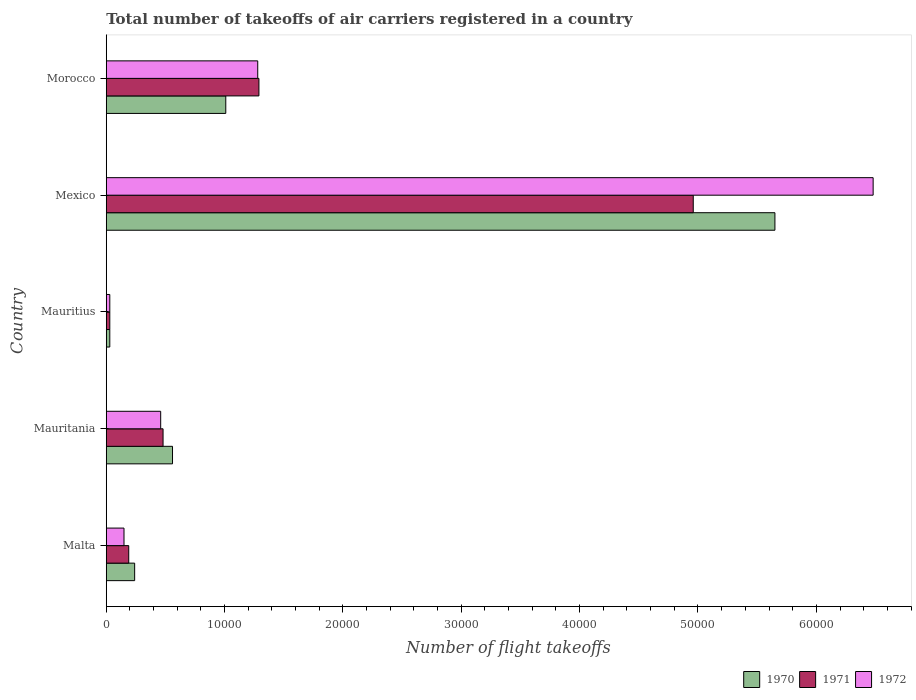How many groups of bars are there?
Keep it short and to the point. 5. How many bars are there on the 4th tick from the bottom?
Provide a short and direct response. 3. What is the label of the 3rd group of bars from the top?
Your response must be concise. Mauritius. What is the total number of flight takeoffs in 1970 in Mauritius?
Your answer should be very brief. 300. Across all countries, what is the maximum total number of flight takeoffs in 1971?
Your answer should be very brief. 4.96e+04. Across all countries, what is the minimum total number of flight takeoffs in 1972?
Offer a very short reply. 300. In which country was the total number of flight takeoffs in 1971 minimum?
Keep it short and to the point. Mauritius. What is the total total number of flight takeoffs in 1971 in the graph?
Ensure brevity in your answer.  6.95e+04. What is the difference between the total number of flight takeoffs in 1970 in Mexico and that in Morocco?
Keep it short and to the point. 4.64e+04. What is the difference between the total number of flight takeoffs in 1970 in Morocco and the total number of flight takeoffs in 1972 in Malta?
Provide a short and direct response. 8600. What is the average total number of flight takeoffs in 1970 per country?
Offer a terse response. 1.50e+04. What is the difference between the total number of flight takeoffs in 1971 and total number of flight takeoffs in 1970 in Mexico?
Keep it short and to the point. -6900. In how many countries, is the total number of flight takeoffs in 1970 greater than 14000 ?
Ensure brevity in your answer.  1. What is the ratio of the total number of flight takeoffs in 1971 in Mauritania to that in Mexico?
Provide a succinct answer. 0.1. Is the total number of flight takeoffs in 1972 in Mauritius less than that in Morocco?
Keep it short and to the point. Yes. What is the difference between the highest and the second highest total number of flight takeoffs in 1970?
Offer a very short reply. 4.64e+04. What is the difference between the highest and the lowest total number of flight takeoffs in 1970?
Ensure brevity in your answer.  5.62e+04. In how many countries, is the total number of flight takeoffs in 1972 greater than the average total number of flight takeoffs in 1972 taken over all countries?
Your answer should be very brief. 1. Is the sum of the total number of flight takeoffs in 1970 in Mauritania and Morocco greater than the maximum total number of flight takeoffs in 1971 across all countries?
Offer a very short reply. No. What does the 2nd bar from the top in Morocco represents?
Your response must be concise. 1971. What does the 2nd bar from the bottom in Mauritania represents?
Offer a very short reply. 1971. Is it the case that in every country, the sum of the total number of flight takeoffs in 1970 and total number of flight takeoffs in 1972 is greater than the total number of flight takeoffs in 1971?
Provide a short and direct response. Yes. How many bars are there?
Make the answer very short. 15. How many countries are there in the graph?
Give a very brief answer. 5. Does the graph contain grids?
Your answer should be very brief. No. What is the title of the graph?
Your answer should be very brief. Total number of takeoffs of air carriers registered in a country. Does "1986" appear as one of the legend labels in the graph?
Provide a short and direct response. No. What is the label or title of the X-axis?
Offer a terse response. Number of flight takeoffs. What is the label or title of the Y-axis?
Offer a terse response. Country. What is the Number of flight takeoffs of 1970 in Malta?
Offer a terse response. 2400. What is the Number of flight takeoffs in 1971 in Malta?
Your response must be concise. 1900. What is the Number of flight takeoffs of 1972 in Malta?
Ensure brevity in your answer.  1500. What is the Number of flight takeoffs in 1970 in Mauritania?
Give a very brief answer. 5600. What is the Number of flight takeoffs in 1971 in Mauritania?
Offer a terse response. 4800. What is the Number of flight takeoffs in 1972 in Mauritania?
Offer a terse response. 4600. What is the Number of flight takeoffs of 1970 in Mauritius?
Give a very brief answer. 300. What is the Number of flight takeoffs in 1971 in Mauritius?
Your answer should be very brief. 300. What is the Number of flight takeoffs in 1972 in Mauritius?
Give a very brief answer. 300. What is the Number of flight takeoffs in 1970 in Mexico?
Your response must be concise. 5.65e+04. What is the Number of flight takeoffs of 1971 in Mexico?
Ensure brevity in your answer.  4.96e+04. What is the Number of flight takeoffs of 1972 in Mexico?
Provide a succinct answer. 6.48e+04. What is the Number of flight takeoffs in 1970 in Morocco?
Your answer should be very brief. 1.01e+04. What is the Number of flight takeoffs of 1971 in Morocco?
Provide a short and direct response. 1.29e+04. What is the Number of flight takeoffs of 1972 in Morocco?
Keep it short and to the point. 1.28e+04. Across all countries, what is the maximum Number of flight takeoffs in 1970?
Your answer should be very brief. 5.65e+04. Across all countries, what is the maximum Number of flight takeoffs of 1971?
Give a very brief answer. 4.96e+04. Across all countries, what is the maximum Number of flight takeoffs in 1972?
Keep it short and to the point. 6.48e+04. Across all countries, what is the minimum Number of flight takeoffs in 1970?
Provide a succinct answer. 300. Across all countries, what is the minimum Number of flight takeoffs in 1971?
Your answer should be very brief. 300. Across all countries, what is the minimum Number of flight takeoffs of 1972?
Keep it short and to the point. 300. What is the total Number of flight takeoffs in 1970 in the graph?
Provide a succinct answer. 7.49e+04. What is the total Number of flight takeoffs in 1971 in the graph?
Offer a very short reply. 6.95e+04. What is the total Number of flight takeoffs in 1972 in the graph?
Make the answer very short. 8.40e+04. What is the difference between the Number of flight takeoffs of 1970 in Malta and that in Mauritania?
Your response must be concise. -3200. What is the difference between the Number of flight takeoffs in 1971 in Malta and that in Mauritania?
Ensure brevity in your answer.  -2900. What is the difference between the Number of flight takeoffs of 1972 in Malta and that in Mauritania?
Offer a terse response. -3100. What is the difference between the Number of flight takeoffs of 1970 in Malta and that in Mauritius?
Your answer should be compact. 2100. What is the difference between the Number of flight takeoffs in 1971 in Malta and that in Mauritius?
Offer a very short reply. 1600. What is the difference between the Number of flight takeoffs in 1972 in Malta and that in Mauritius?
Keep it short and to the point. 1200. What is the difference between the Number of flight takeoffs in 1970 in Malta and that in Mexico?
Provide a succinct answer. -5.41e+04. What is the difference between the Number of flight takeoffs in 1971 in Malta and that in Mexico?
Your answer should be very brief. -4.77e+04. What is the difference between the Number of flight takeoffs in 1972 in Malta and that in Mexico?
Provide a succinct answer. -6.33e+04. What is the difference between the Number of flight takeoffs in 1970 in Malta and that in Morocco?
Provide a succinct answer. -7700. What is the difference between the Number of flight takeoffs of 1971 in Malta and that in Morocco?
Your answer should be compact. -1.10e+04. What is the difference between the Number of flight takeoffs of 1972 in Malta and that in Morocco?
Your answer should be very brief. -1.13e+04. What is the difference between the Number of flight takeoffs in 1970 in Mauritania and that in Mauritius?
Offer a terse response. 5300. What is the difference between the Number of flight takeoffs of 1971 in Mauritania and that in Mauritius?
Keep it short and to the point. 4500. What is the difference between the Number of flight takeoffs in 1972 in Mauritania and that in Mauritius?
Your answer should be compact. 4300. What is the difference between the Number of flight takeoffs of 1970 in Mauritania and that in Mexico?
Your answer should be very brief. -5.09e+04. What is the difference between the Number of flight takeoffs in 1971 in Mauritania and that in Mexico?
Provide a short and direct response. -4.48e+04. What is the difference between the Number of flight takeoffs of 1972 in Mauritania and that in Mexico?
Offer a terse response. -6.02e+04. What is the difference between the Number of flight takeoffs in 1970 in Mauritania and that in Morocco?
Provide a succinct answer. -4500. What is the difference between the Number of flight takeoffs in 1971 in Mauritania and that in Morocco?
Your answer should be compact. -8100. What is the difference between the Number of flight takeoffs of 1972 in Mauritania and that in Morocco?
Your answer should be compact. -8200. What is the difference between the Number of flight takeoffs of 1970 in Mauritius and that in Mexico?
Provide a succinct answer. -5.62e+04. What is the difference between the Number of flight takeoffs of 1971 in Mauritius and that in Mexico?
Your response must be concise. -4.93e+04. What is the difference between the Number of flight takeoffs in 1972 in Mauritius and that in Mexico?
Your answer should be very brief. -6.45e+04. What is the difference between the Number of flight takeoffs of 1970 in Mauritius and that in Morocco?
Offer a very short reply. -9800. What is the difference between the Number of flight takeoffs in 1971 in Mauritius and that in Morocco?
Your response must be concise. -1.26e+04. What is the difference between the Number of flight takeoffs of 1972 in Mauritius and that in Morocco?
Your response must be concise. -1.25e+04. What is the difference between the Number of flight takeoffs of 1970 in Mexico and that in Morocco?
Your answer should be very brief. 4.64e+04. What is the difference between the Number of flight takeoffs in 1971 in Mexico and that in Morocco?
Your response must be concise. 3.67e+04. What is the difference between the Number of flight takeoffs in 1972 in Mexico and that in Morocco?
Ensure brevity in your answer.  5.20e+04. What is the difference between the Number of flight takeoffs in 1970 in Malta and the Number of flight takeoffs in 1971 in Mauritania?
Provide a short and direct response. -2400. What is the difference between the Number of flight takeoffs in 1970 in Malta and the Number of flight takeoffs in 1972 in Mauritania?
Provide a succinct answer. -2200. What is the difference between the Number of flight takeoffs in 1971 in Malta and the Number of flight takeoffs in 1972 in Mauritania?
Provide a succinct answer. -2700. What is the difference between the Number of flight takeoffs in 1970 in Malta and the Number of flight takeoffs in 1971 in Mauritius?
Your response must be concise. 2100. What is the difference between the Number of flight takeoffs in 1970 in Malta and the Number of flight takeoffs in 1972 in Mauritius?
Provide a succinct answer. 2100. What is the difference between the Number of flight takeoffs of 1971 in Malta and the Number of flight takeoffs of 1972 in Mauritius?
Give a very brief answer. 1600. What is the difference between the Number of flight takeoffs in 1970 in Malta and the Number of flight takeoffs in 1971 in Mexico?
Your response must be concise. -4.72e+04. What is the difference between the Number of flight takeoffs of 1970 in Malta and the Number of flight takeoffs of 1972 in Mexico?
Give a very brief answer. -6.24e+04. What is the difference between the Number of flight takeoffs of 1971 in Malta and the Number of flight takeoffs of 1972 in Mexico?
Your answer should be very brief. -6.29e+04. What is the difference between the Number of flight takeoffs of 1970 in Malta and the Number of flight takeoffs of 1971 in Morocco?
Give a very brief answer. -1.05e+04. What is the difference between the Number of flight takeoffs of 1970 in Malta and the Number of flight takeoffs of 1972 in Morocco?
Keep it short and to the point. -1.04e+04. What is the difference between the Number of flight takeoffs in 1971 in Malta and the Number of flight takeoffs in 1972 in Morocco?
Provide a short and direct response. -1.09e+04. What is the difference between the Number of flight takeoffs in 1970 in Mauritania and the Number of flight takeoffs in 1971 in Mauritius?
Make the answer very short. 5300. What is the difference between the Number of flight takeoffs in 1970 in Mauritania and the Number of flight takeoffs in 1972 in Mauritius?
Give a very brief answer. 5300. What is the difference between the Number of flight takeoffs in 1971 in Mauritania and the Number of flight takeoffs in 1972 in Mauritius?
Your answer should be very brief. 4500. What is the difference between the Number of flight takeoffs in 1970 in Mauritania and the Number of flight takeoffs in 1971 in Mexico?
Your answer should be compact. -4.40e+04. What is the difference between the Number of flight takeoffs in 1970 in Mauritania and the Number of flight takeoffs in 1972 in Mexico?
Provide a short and direct response. -5.92e+04. What is the difference between the Number of flight takeoffs of 1970 in Mauritania and the Number of flight takeoffs of 1971 in Morocco?
Provide a short and direct response. -7300. What is the difference between the Number of flight takeoffs in 1970 in Mauritania and the Number of flight takeoffs in 1972 in Morocco?
Provide a short and direct response. -7200. What is the difference between the Number of flight takeoffs of 1971 in Mauritania and the Number of flight takeoffs of 1972 in Morocco?
Make the answer very short. -8000. What is the difference between the Number of flight takeoffs in 1970 in Mauritius and the Number of flight takeoffs in 1971 in Mexico?
Offer a very short reply. -4.93e+04. What is the difference between the Number of flight takeoffs in 1970 in Mauritius and the Number of flight takeoffs in 1972 in Mexico?
Make the answer very short. -6.45e+04. What is the difference between the Number of flight takeoffs of 1971 in Mauritius and the Number of flight takeoffs of 1972 in Mexico?
Provide a succinct answer. -6.45e+04. What is the difference between the Number of flight takeoffs of 1970 in Mauritius and the Number of flight takeoffs of 1971 in Morocco?
Give a very brief answer. -1.26e+04. What is the difference between the Number of flight takeoffs of 1970 in Mauritius and the Number of flight takeoffs of 1972 in Morocco?
Give a very brief answer. -1.25e+04. What is the difference between the Number of flight takeoffs in 1971 in Mauritius and the Number of flight takeoffs in 1972 in Morocco?
Make the answer very short. -1.25e+04. What is the difference between the Number of flight takeoffs in 1970 in Mexico and the Number of flight takeoffs in 1971 in Morocco?
Give a very brief answer. 4.36e+04. What is the difference between the Number of flight takeoffs of 1970 in Mexico and the Number of flight takeoffs of 1972 in Morocco?
Your answer should be very brief. 4.37e+04. What is the difference between the Number of flight takeoffs of 1971 in Mexico and the Number of flight takeoffs of 1972 in Morocco?
Your response must be concise. 3.68e+04. What is the average Number of flight takeoffs in 1970 per country?
Give a very brief answer. 1.50e+04. What is the average Number of flight takeoffs of 1971 per country?
Your response must be concise. 1.39e+04. What is the average Number of flight takeoffs of 1972 per country?
Give a very brief answer. 1.68e+04. What is the difference between the Number of flight takeoffs of 1970 and Number of flight takeoffs of 1971 in Malta?
Provide a short and direct response. 500. What is the difference between the Number of flight takeoffs of 1970 and Number of flight takeoffs of 1972 in Malta?
Give a very brief answer. 900. What is the difference between the Number of flight takeoffs in 1971 and Number of flight takeoffs in 1972 in Malta?
Offer a terse response. 400. What is the difference between the Number of flight takeoffs of 1970 and Number of flight takeoffs of 1971 in Mauritania?
Make the answer very short. 800. What is the difference between the Number of flight takeoffs of 1971 and Number of flight takeoffs of 1972 in Mauritania?
Offer a terse response. 200. What is the difference between the Number of flight takeoffs in 1971 and Number of flight takeoffs in 1972 in Mauritius?
Your answer should be compact. 0. What is the difference between the Number of flight takeoffs of 1970 and Number of flight takeoffs of 1971 in Mexico?
Give a very brief answer. 6900. What is the difference between the Number of flight takeoffs of 1970 and Number of flight takeoffs of 1972 in Mexico?
Give a very brief answer. -8300. What is the difference between the Number of flight takeoffs in 1971 and Number of flight takeoffs in 1972 in Mexico?
Offer a terse response. -1.52e+04. What is the difference between the Number of flight takeoffs in 1970 and Number of flight takeoffs in 1971 in Morocco?
Make the answer very short. -2800. What is the difference between the Number of flight takeoffs of 1970 and Number of flight takeoffs of 1972 in Morocco?
Offer a terse response. -2700. What is the ratio of the Number of flight takeoffs of 1970 in Malta to that in Mauritania?
Keep it short and to the point. 0.43. What is the ratio of the Number of flight takeoffs in 1971 in Malta to that in Mauritania?
Provide a succinct answer. 0.4. What is the ratio of the Number of flight takeoffs of 1972 in Malta to that in Mauritania?
Ensure brevity in your answer.  0.33. What is the ratio of the Number of flight takeoffs in 1971 in Malta to that in Mauritius?
Offer a very short reply. 6.33. What is the ratio of the Number of flight takeoffs in 1970 in Malta to that in Mexico?
Make the answer very short. 0.04. What is the ratio of the Number of flight takeoffs in 1971 in Malta to that in Mexico?
Make the answer very short. 0.04. What is the ratio of the Number of flight takeoffs in 1972 in Malta to that in Mexico?
Offer a very short reply. 0.02. What is the ratio of the Number of flight takeoffs in 1970 in Malta to that in Morocco?
Your answer should be very brief. 0.24. What is the ratio of the Number of flight takeoffs in 1971 in Malta to that in Morocco?
Your answer should be very brief. 0.15. What is the ratio of the Number of flight takeoffs of 1972 in Malta to that in Morocco?
Offer a very short reply. 0.12. What is the ratio of the Number of flight takeoffs in 1970 in Mauritania to that in Mauritius?
Keep it short and to the point. 18.67. What is the ratio of the Number of flight takeoffs of 1972 in Mauritania to that in Mauritius?
Give a very brief answer. 15.33. What is the ratio of the Number of flight takeoffs in 1970 in Mauritania to that in Mexico?
Make the answer very short. 0.1. What is the ratio of the Number of flight takeoffs of 1971 in Mauritania to that in Mexico?
Give a very brief answer. 0.1. What is the ratio of the Number of flight takeoffs of 1972 in Mauritania to that in Mexico?
Ensure brevity in your answer.  0.07. What is the ratio of the Number of flight takeoffs of 1970 in Mauritania to that in Morocco?
Your answer should be very brief. 0.55. What is the ratio of the Number of flight takeoffs of 1971 in Mauritania to that in Morocco?
Provide a short and direct response. 0.37. What is the ratio of the Number of flight takeoffs of 1972 in Mauritania to that in Morocco?
Ensure brevity in your answer.  0.36. What is the ratio of the Number of flight takeoffs of 1970 in Mauritius to that in Mexico?
Your answer should be compact. 0.01. What is the ratio of the Number of flight takeoffs in 1971 in Mauritius to that in Mexico?
Make the answer very short. 0.01. What is the ratio of the Number of flight takeoffs of 1972 in Mauritius to that in Mexico?
Your answer should be very brief. 0. What is the ratio of the Number of flight takeoffs of 1970 in Mauritius to that in Morocco?
Provide a succinct answer. 0.03. What is the ratio of the Number of flight takeoffs in 1971 in Mauritius to that in Morocco?
Provide a short and direct response. 0.02. What is the ratio of the Number of flight takeoffs of 1972 in Mauritius to that in Morocco?
Keep it short and to the point. 0.02. What is the ratio of the Number of flight takeoffs in 1970 in Mexico to that in Morocco?
Your answer should be very brief. 5.59. What is the ratio of the Number of flight takeoffs in 1971 in Mexico to that in Morocco?
Your answer should be very brief. 3.85. What is the ratio of the Number of flight takeoffs in 1972 in Mexico to that in Morocco?
Make the answer very short. 5.06. What is the difference between the highest and the second highest Number of flight takeoffs of 1970?
Give a very brief answer. 4.64e+04. What is the difference between the highest and the second highest Number of flight takeoffs of 1971?
Your answer should be compact. 3.67e+04. What is the difference between the highest and the second highest Number of flight takeoffs of 1972?
Give a very brief answer. 5.20e+04. What is the difference between the highest and the lowest Number of flight takeoffs of 1970?
Your answer should be very brief. 5.62e+04. What is the difference between the highest and the lowest Number of flight takeoffs in 1971?
Make the answer very short. 4.93e+04. What is the difference between the highest and the lowest Number of flight takeoffs of 1972?
Your answer should be compact. 6.45e+04. 